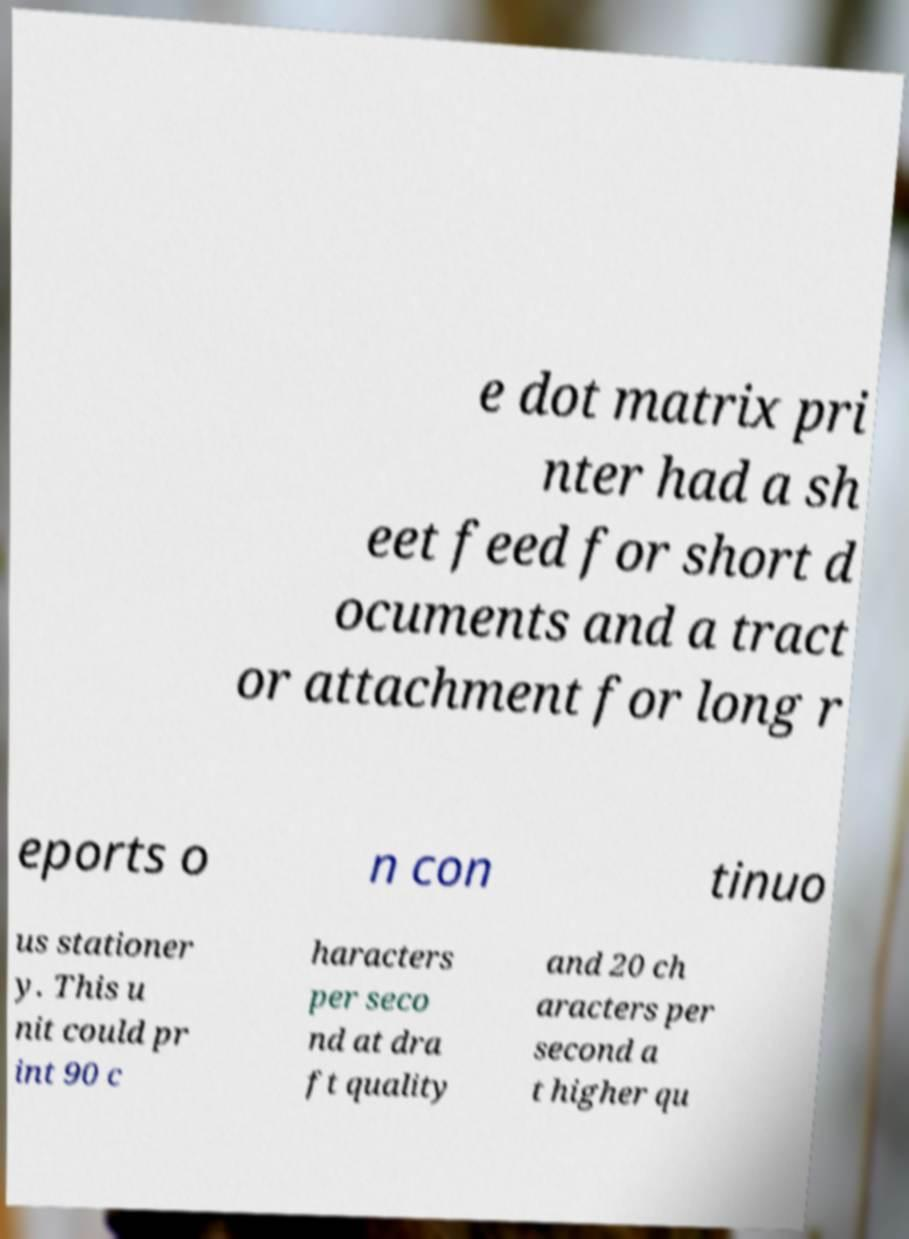Could you assist in decoding the text presented in this image and type it out clearly? e dot matrix pri nter had a sh eet feed for short d ocuments and a tract or attachment for long r eports o n con tinuo us stationer y. This u nit could pr int 90 c haracters per seco nd at dra ft quality and 20 ch aracters per second a t higher qu 